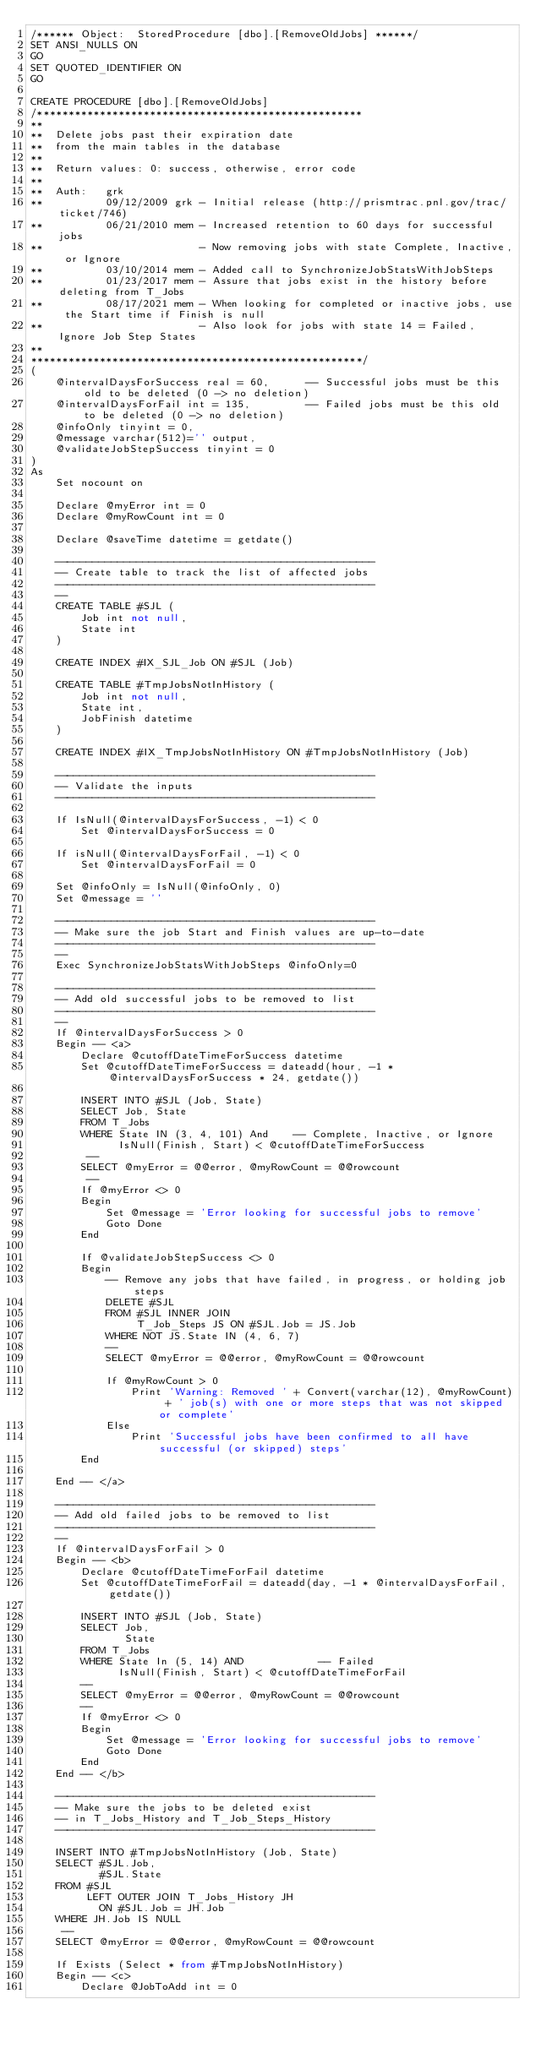Convert code to text. <code><loc_0><loc_0><loc_500><loc_500><_SQL_>/****** Object:  StoredProcedure [dbo].[RemoveOldJobs] ******/
SET ANSI_NULLS ON
GO
SET QUOTED_IDENTIFIER ON
GO

CREATE PROCEDURE [dbo].[RemoveOldJobs]
/****************************************************
**
**  Delete jobs past their expiration date
**  from the main tables in the database
**
**  Return values: 0: success, otherwise, error code
**
**  Auth:   grk
**          09/12/2009 grk - Initial release (http://prismtrac.pnl.gov/trac/ticket/746)
**          06/21/2010 mem - Increased retention to 60 days for successful jobs
**                         - Now removing jobs with state Complete, Inactive, or Ignore
**          03/10/2014 mem - Added call to SynchronizeJobStatsWithJobSteps
**          01/23/2017 mem - Assure that jobs exist in the history before deleting from T_Jobs
**          08/17/2021 mem - When looking for completed or inactive jobs, use the Start time if Finish is null
**                         - Also look for jobs with state 14 = Failed, Ignore Job Step States
**
*****************************************************/
(
    @intervalDaysForSuccess real = 60,      -- Successful jobs must be this old to be deleted (0 -> no deletion)
    @intervalDaysForFail int = 135,         -- Failed jobs must be this old to be deleted (0 -> no deletion)
    @infoOnly tinyint = 0,
    @message varchar(512)='' output,
    @validateJobStepSuccess tinyint = 0
)
As
    Set nocount on

    Declare @myError int = 0
    Declare @myRowCount int = 0

    Declare @saveTime datetime = getdate()

    ---------------------------------------------------
    -- Create table to track the list of affected jobs
    ---------------------------------------------------
    --
    CREATE TABLE #SJL (
        Job int not null,
        State int
    )

    CREATE INDEX #IX_SJL_Job ON #SJL (Job)

    CREATE TABLE #TmpJobsNotInHistory (
        Job int not null,
        State int,
        JobFinish datetime
    )

    CREATE INDEX #IX_TmpJobsNotInHistory ON #TmpJobsNotInHistory (Job)

    ---------------------------------------------------
    -- Validate the inputs
    ---------------------------------------------------

    If IsNull(@intervalDaysForSuccess, -1) < 0
        Set @intervalDaysForSuccess = 0

    If isNull(@intervalDaysForFail, -1) < 0
        Set @intervalDaysForFail = 0

    Set @infoOnly = IsNull(@infoOnly, 0)
    Set @message = ''

    ---------------------------------------------------
    -- Make sure the job Start and Finish values are up-to-date
    ---------------------------------------------------
    --
    Exec SynchronizeJobStatsWithJobSteps @infoOnly=0

    ---------------------------------------------------
    -- Add old successful jobs to be removed to list
    ---------------------------------------------------
    --
    If @intervalDaysForSuccess > 0
    Begin -- <a>
        Declare @cutoffDateTimeForSuccess datetime
        Set @cutoffDateTimeForSuccess = dateadd(hour, -1 * @intervalDaysForSuccess * 24, getdate())

        INSERT INTO #SJL (Job, State)
        SELECT Job, State
        FROM T_Jobs
        WHERE State IN (3, 4, 101) And    -- Complete, Inactive, or Ignore
              IsNull(Finish, Start) < @cutoffDateTimeForSuccess
         --
        SELECT @myError = @@error, @myRowCount = @@rowcount
         --
        If @myError <> 0
        Begin
            Set @message = 'Error looking for successful jobs to remove'
            Goto Done
        End

        If @validateJobStepSuccess <> 0
        Begin
            -- Remove any jobs that have failed, in progress, or holding job steps
            DELETE #SJL
            FROM #SJL INNER JOIN
                 T_Job_Steps JS ON #SJL.Job = JS.Job
            WHERE NOT JS.State IN (4, 6, 7)
            --
            SELECT @myError = @@error, @myRowCount = @@rowcount

            If @myRowCount > 0
                Print 'Warning: Removed ' + Convert(varchar(12), @myRowCount) + ' job(s) with one or more steps that was not skipped or complete'
            Else
                Print 'Successful jobs have been confirmed to all have successful (or skipped) steps'
        End

    End -- </a>

    ---------------------------------------------------
    -- Add old failed jobs to be removed to list
    ---------------------------------------------------
    --
    If @intervalDaysForFail > 0
    Begin -- <b>
        Declare @cutoffDateTimeForFail datetime
        Set @cutoffDateTimeForFail = dateadd(day, -1 * @intervalDaysForFail, getdate())

        INSERT INTO #SJL (Job, State)
        SELECT Job,
               State
        FROM T_Jobs
        WHERE State In (5, 14) AND            -- Failed
              IsNull(Finish, Start) < @cutoffDateTimeForFail
        --
        SELECT @myError = @@error, @myRowCount = @@rowcount
        --
        If @myError <> 0
        Begin
            Set @message = 'Error looking for successful jobs to remove'
            Goto Done
        End
    End -- </b>

    ---------------------------------------------------
    -- Make sure the jobs to be deleted exist
    -- in T_Jobs_History and T_Job_Steps_History
    ---------------------------------------------------

    INSERT INTO #TmpJobsNotInHistory (Job, State)
    SELECT #SJL.Job,
           #SJL.State
    FROM #SJL
         LEFT OUTER JOIN T_Jobs_History JH
           ON #SJL.Job = JH.Job
    WHERE JH.Job IS NULL
     --
    SELECT @myError = @@error, @myRowCount = @@rowcount

    If Exists (Select * from #TmpJobsNotInHistory)
    Begin -- <c>
        Declare @JobToAdd int = 0</code> 